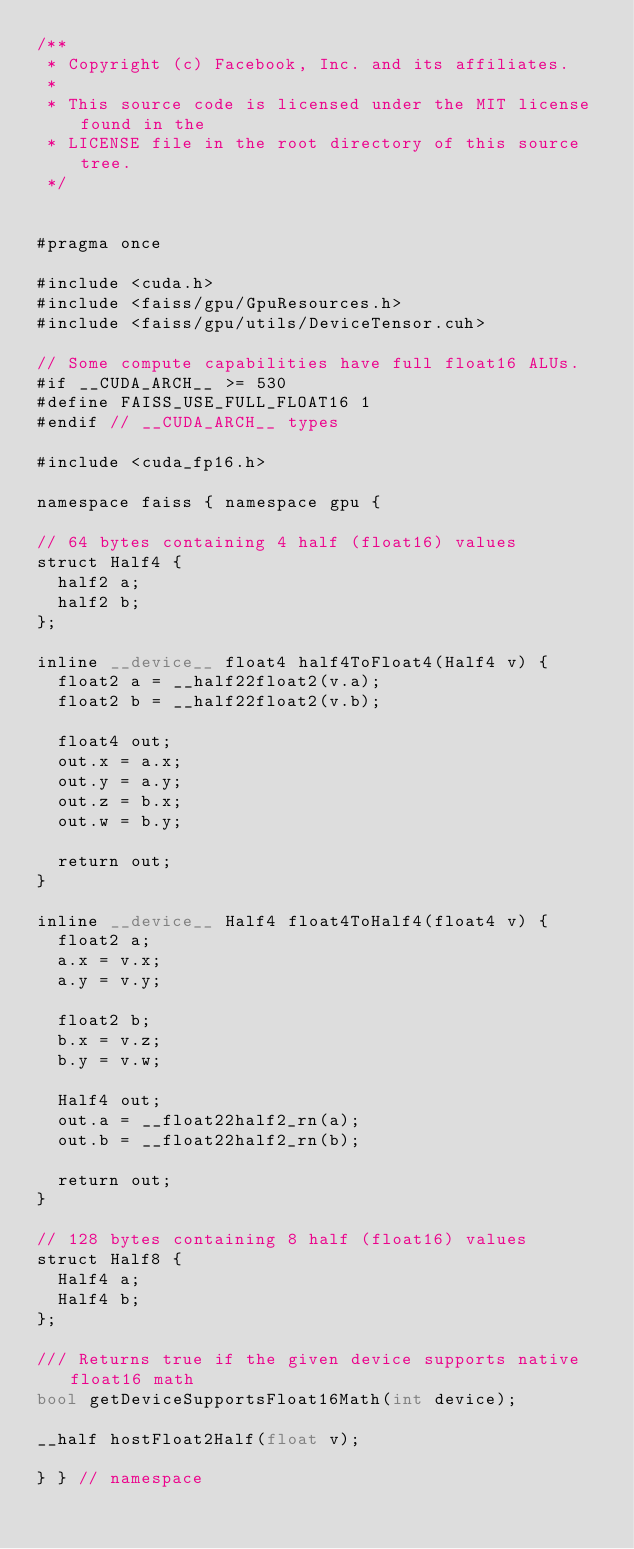Convert code to text. <code><loc_0><loc_0><loc_500><loc_500><_Cuda_>/**
 * Copyright (c) Facebook, Inc. and its affiliates.
 *
 * This source code is licensed under the MIT license found in the
 * LICENSE file in the root directory of this source tree.
 */


#pragma once

#include <cuda.h>
#include <faiss/gpu/GpuResources.h>
#include <faiss/gpu/utils/DeviceTensor.cuh>

// Some compute capabilities have full float16 ALUs.
#if __CUDA_ARCH__ >= 530
#define FAISS_USE_FULL_FLOAT16 1
#endif // __CUDA_ARCH__ types

#include <cuda_fp16.h>

namespace faiss { namespace gpu {

// 64 bytes containing 4 half (float16) values
struct Half4 {
  half2 a;
  half2 b;
};

inline __device__ float4 half4ToFloat4(Half4 v) {
  float2 a = __half22float2(v.a);
  float2 b = __half22float2(v.b);

  float4 out;
  out.x = a.x;
  out.y = a.y;
  out.z = b.x;
  out.w = b.y;

  return out;
}

inline __device__ Half4 float4ToHalf4(float4 v) {
  float2 a;
  a.x = v.x;
  a.y = v.y;

  float2 b;
  b.x = v.z;
  b.y = v.w;

  Half4 out;
  out.a = __float22half2_rn(a);
  out.b = __float22half2_rn(b);

  return out;
}

// 128 bytes containing 8 half (float16) values
struct Half8 {
  Half4 a;
  Half4 b;
};

/// Returns true if the given device supports native float16 math
bool getDeviceSupportsFloat16Math(int device);

__half hostFloat2Half(float v);

} } // namespace
</code> 